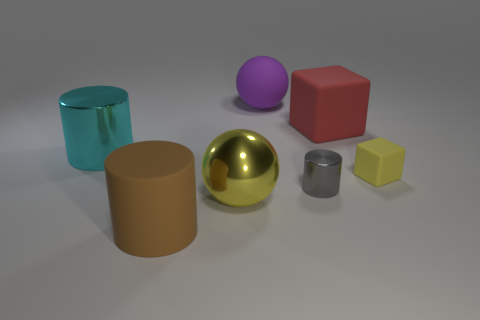The brown object that is the same material as the large purple sphere is what shape?
Make the answer very short. Cylinder. There is a yellow object that is the same material as the gray thing; what is its size?
Offer a terse response. Large. The matte object that is both in front of the cyan shiny cylinder and left of the red object has what shape?
Provide a short and direct response. Cylinder. There is a rubber thing that is left of the big sphere behind the tiny rubber block; what size is it?
Ensure brevity in your answer.  Large. What number of other objects are there of the same color as the small block?
Keep it short and to the point. 1. What material is the large yellow thing?
Offer a terse response. Metal. Are any large cyan matte cylinders visible?
Your answer should be very brief. No. Are there the same number of metallic cylinders behind the large red matte block and big cylinders?
Your response must be concise. No. Is there anything else that is the same material as the purple ball?
Provide a succinct answer. Yes. How many small things are green rubber blocks or brown matte cylinders?
Ensure brevity in your answer.  0. 